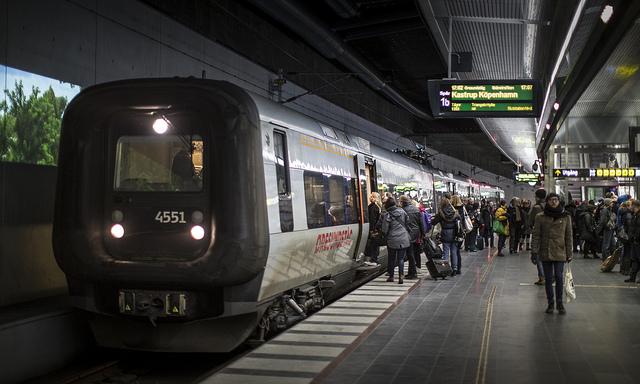What is the number on the train?
Give a very brief answer. 4551. Is the train moving?
Keep it brief. No. What type of transportation is this?
Give a very brief answer. Train. What other mode of transportation is in the photo?
Write a very short answer. Train. What is the train stopped next to?
Write a very short answer. Platform. 